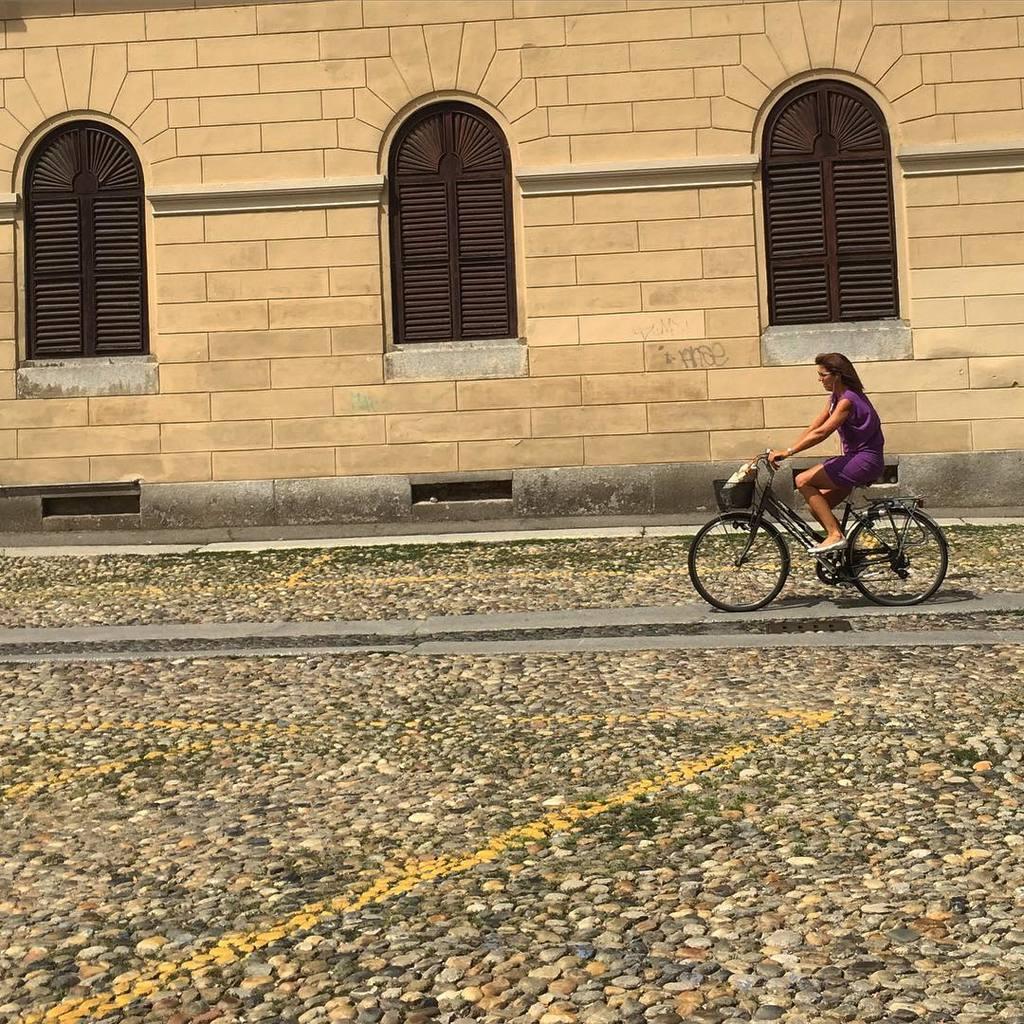In one or two sentences, can you explain what this image depicts? In this picture we can see a building with windows and in front of this building we have path with stone structure and on this path woman is riding bicycle bags are attached to this. 